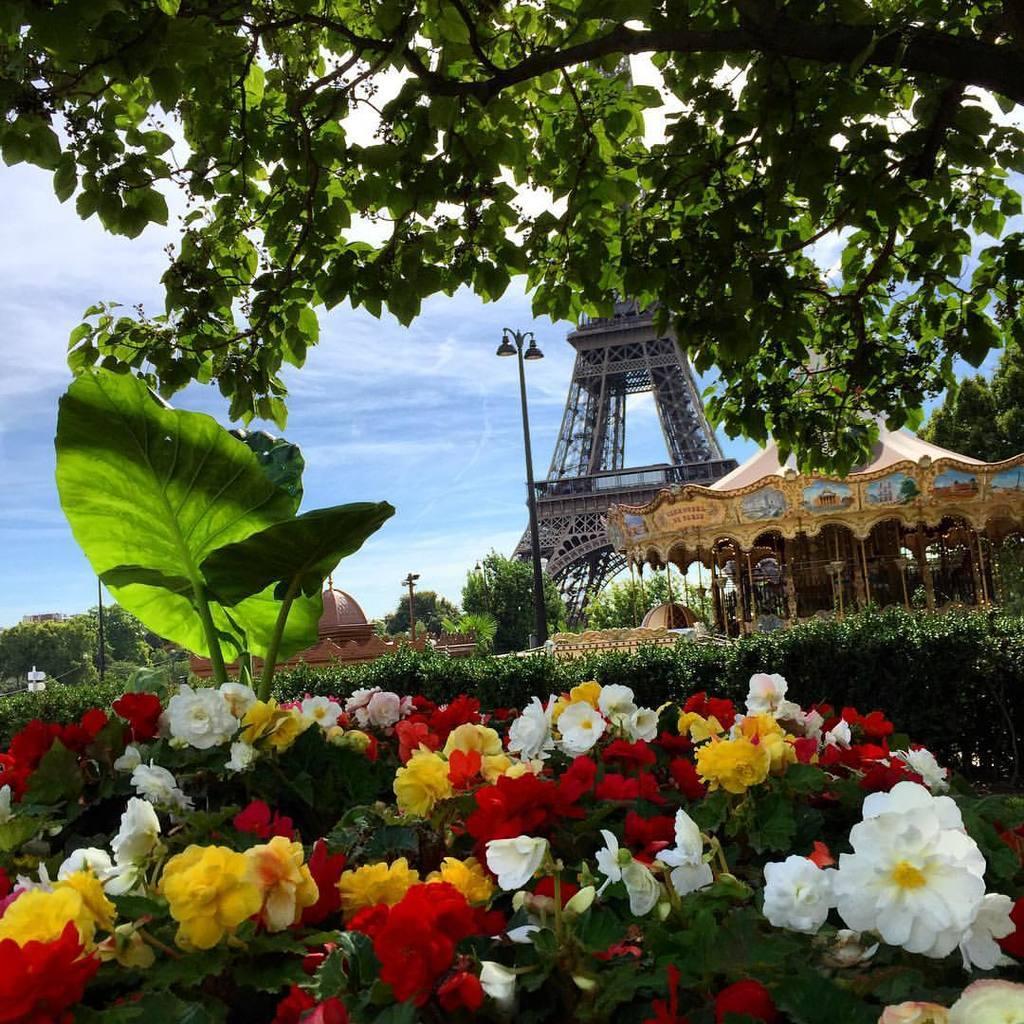In one or two sentences, can you explain what this image depicts? In the picture I can see different color of flowers. Behind the flowers I can see eiffel tower. On the right side of the picture I can see tree with leaves. At the top of the picture I can see sky. 